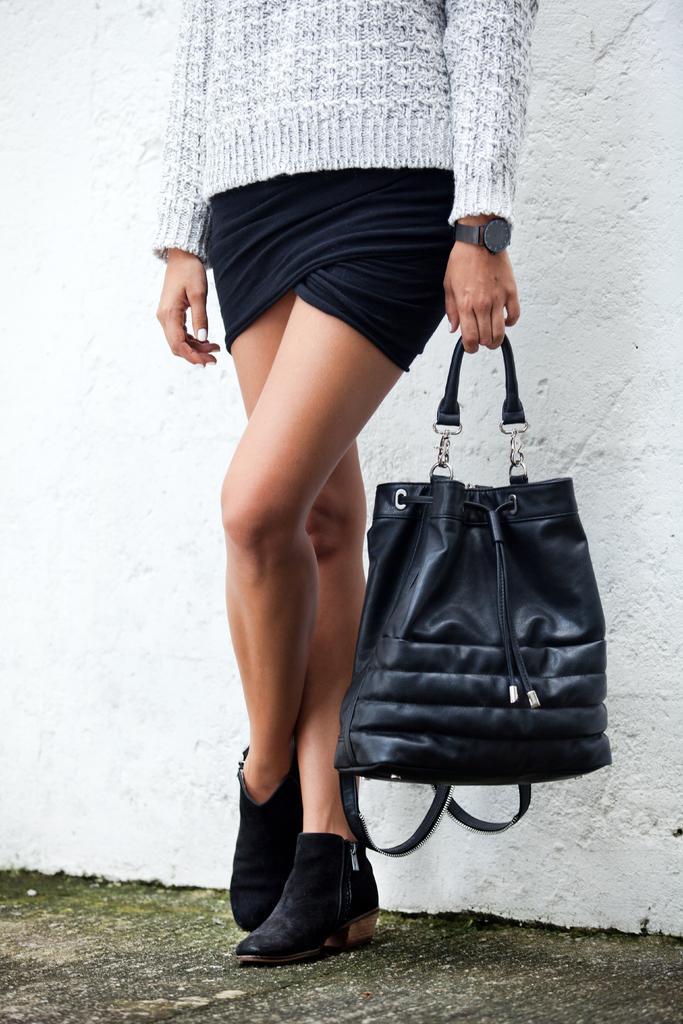Describe this image in one or two sentences. In this picture we can see a lady in ash top,black shorts and black shoes and holding a black bag. 